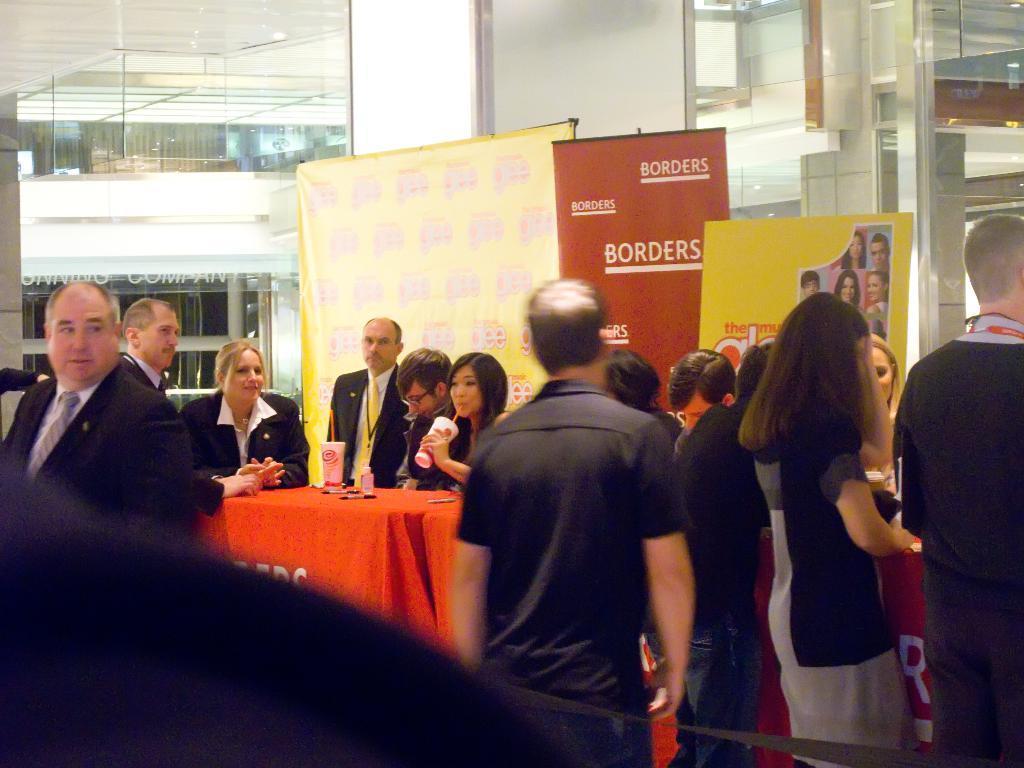In one or two sentences, can you explain what this image depicts? In this picture I can see group of people standing, there are banners, a person holding a paper cup, there are pens, paper box and a paper cup with a straw, on the table, and in the background there is a wall with glass doors. 